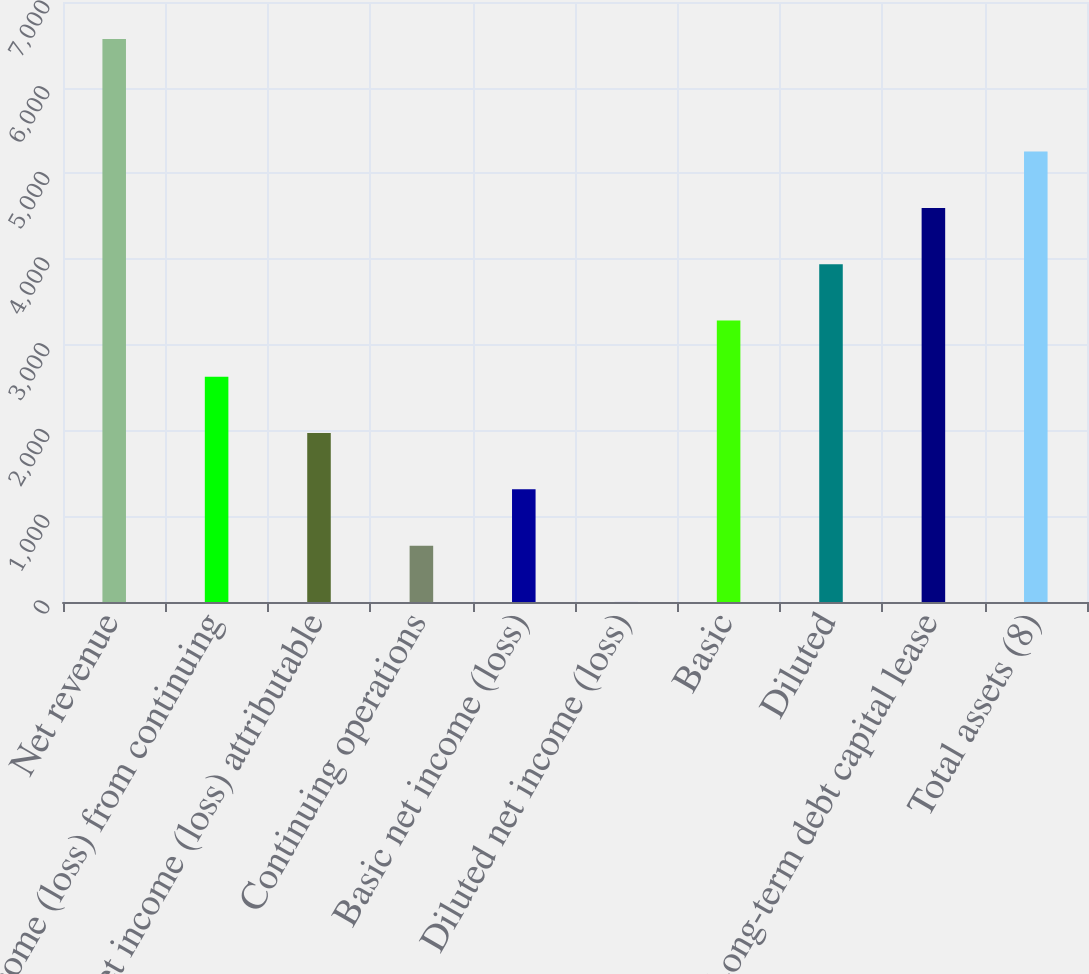Convert chart to OTSL. <chart><loc_0><loc_0><loc_500><loc_500><bar_chart><fcel>Net revenue<fcel>Income (loss) from continuing<fcel>Net income (loss) attributable<fcel>Continuing operations<fcel>Basic net income (loss)<fcel>Diluted net income (loss)<fcel>Basic<fcel>Diluted<fcel>Long-term debt capital lease<fcel>Total assets (8)<nl><fcel>6568<fcel>2627.58<fcel>1970.85<fcel>657.39<fcel>1314.12<fcel>0.66<fcel>3284.31<fcel>3941.04<fcel>4597.77<fcel>5254.5<nl></chart> 